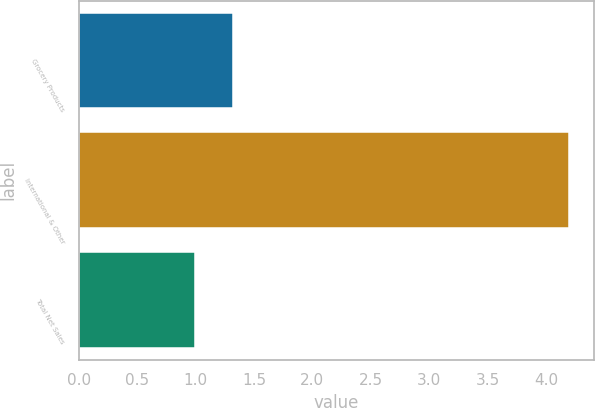<chart> <loc_0><loc_0><loc_500><loc_500><bar_chart><fcel>Grocery Products<fcel>International & Other<fcel>Total Net Sales<nl><fcel>1.32<fcel>4.2<fcel>1<nl></chart> 